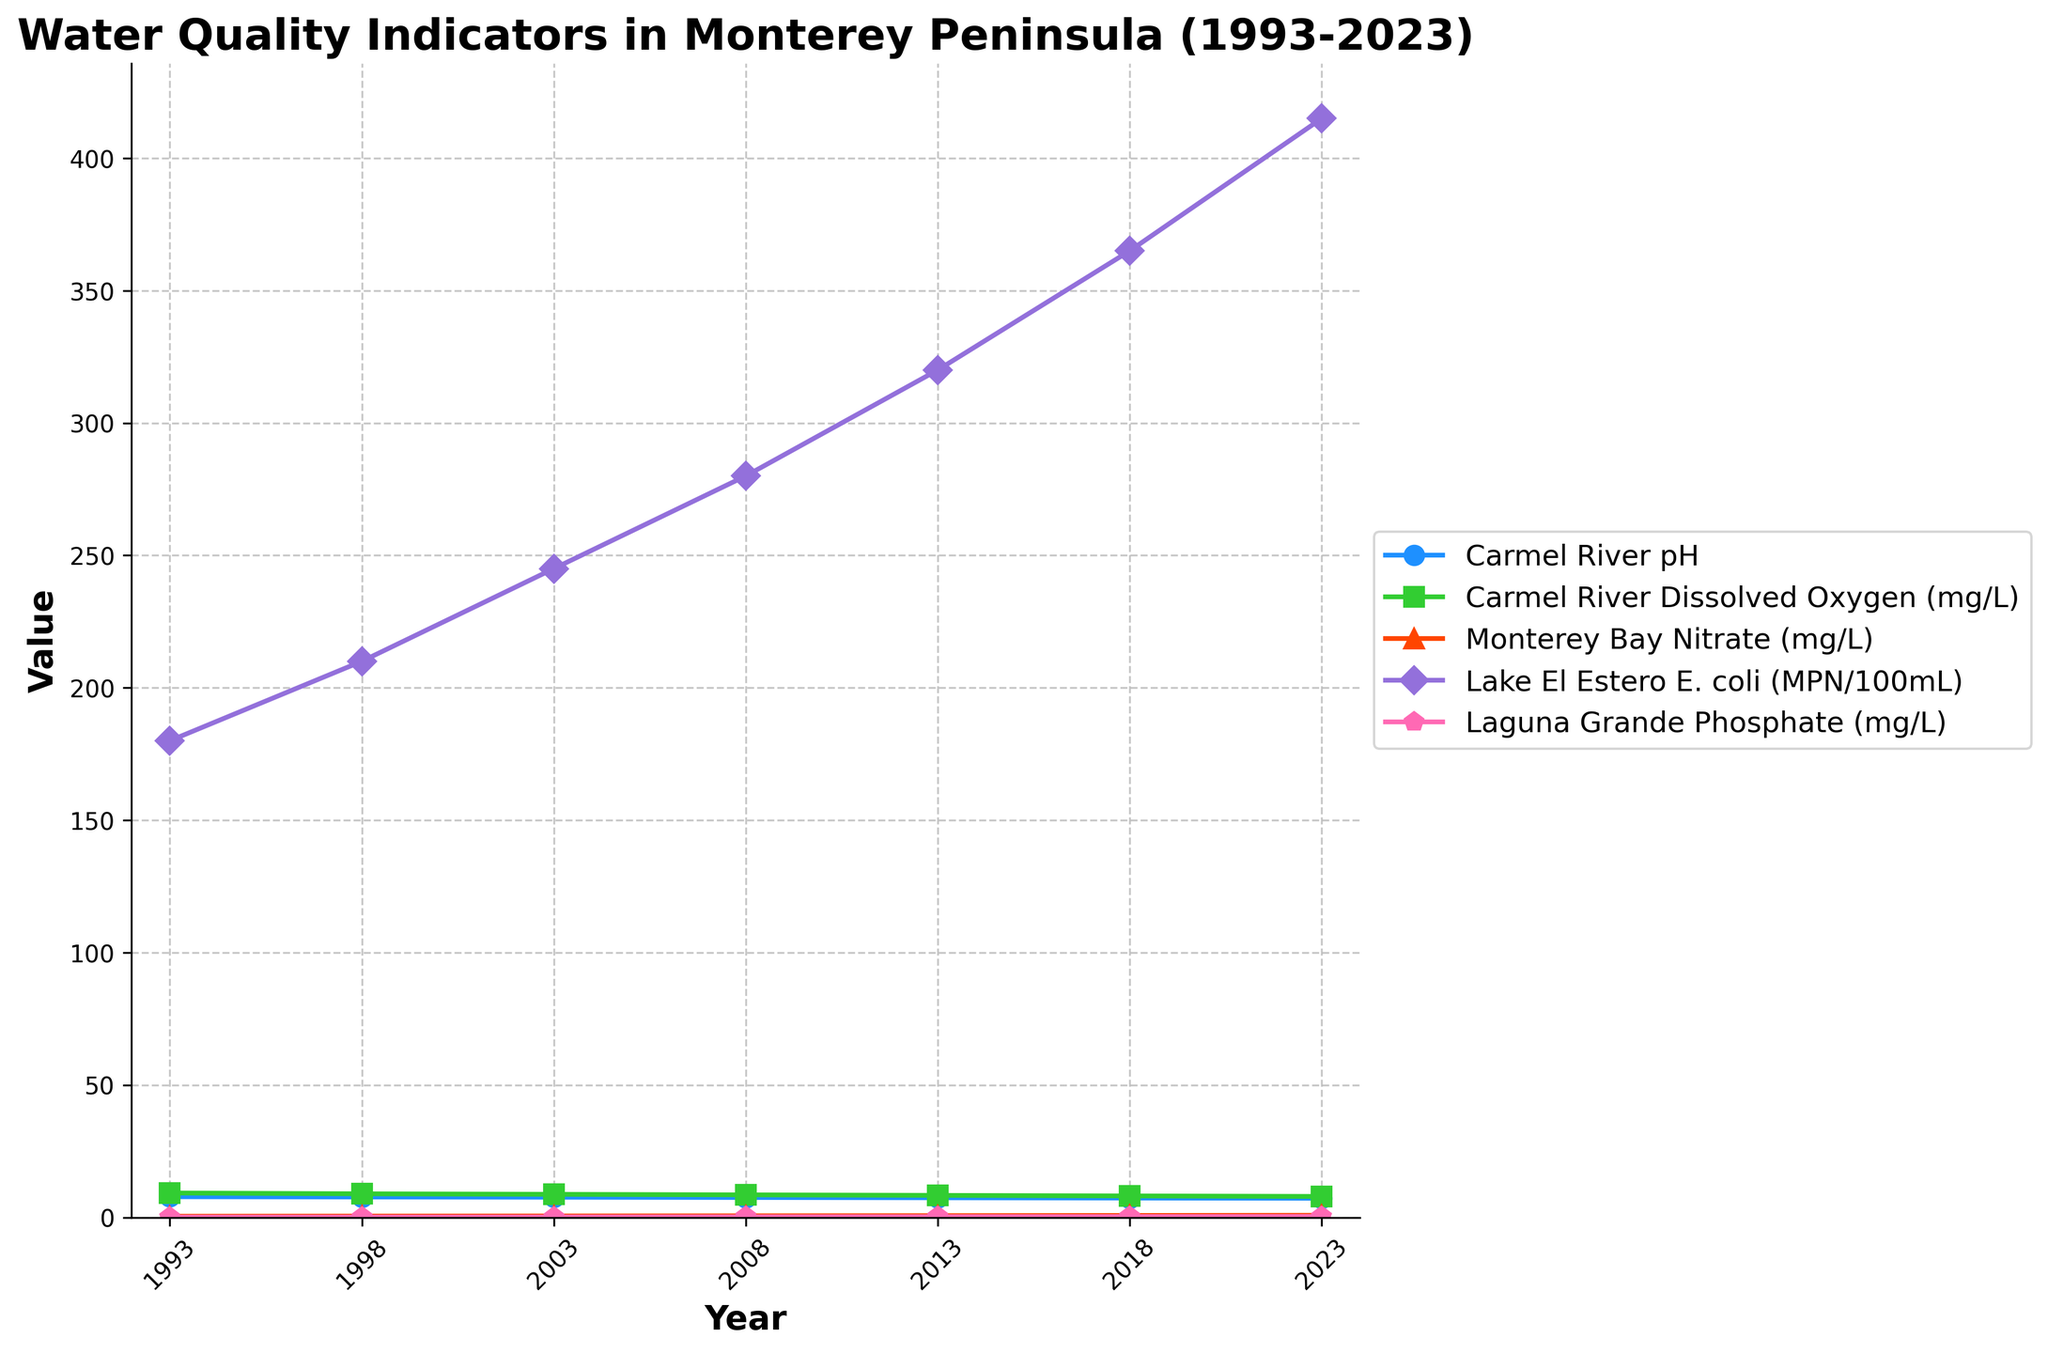What trend is observed in the Carmel River pH from 1993 to 2023? The Carmel River pH decreases from 7.8 in 1993 to 7.2 in 2023. This can be seen by noting the downward slope of the Carmel River pH line on the figure.
Answer: The Carmel River pH decreases How does the level of dissolved oxygen in the Carmel River change over the last 30 years? The Carmel River Dissolved Oxygen decreases from 9.2 mg/L in 1993 to 7.9 mg/L in 2023. The trend is observed as a decreasing line on the graph over the years.
Answer: It decreases Which water quality indicator shows the highest increase over the years? By comparing all the plotted lines, Lake El Estero E. coli shows the steepest increase, going from 180 MPN/100mL in 1993 to 415 MPN/100mL in 2023.
Answer: Lake El Estero E. coli In what year does Monterey Bay Nitrate exceed 0.5 mg/L for the first time? Observing the slope of the Monterey Bay Nitrate line, it first surpasses 0.5 mg/L in 2003.
Answer: 2003 Compare the Carmel River pH in 1998 and 2018. Which year had higher pH levels and by how much? In 1998, the Carmel River pH was 7.7, while in 2018, it was 7.3. To compare, subtract the pH in 2018 from the pH in 1998 (7.7 - 7.3) which equals 0.4.
Answer: 1998 by 0.4 What is the average value of Laguna Grande Phosphate (mg/L) from 1993 to 2023? To calculate the average, sum all the Laguna Grande Phosphate values and divide by the number of years. (0.12 + 0.15 + 0.18 + 0.22 + 0.26 + 0.31 + 0.37) / 7 = 0.23 mg/L.
Answer: 0.23 mg/L How does the trend in Monterey Bay Nitrate compare to the trend in Laguna Grande Phosphate? Both indicators show increasing trends from 1993 to 2023; however, the Monterey Bay Nitrate increases at a more constant and moderate rate, while Laguna Grande Phosphate shows a sharper increase towards the latter years.
Answer: Both are increasing, but Laguna Grande Phosphate increases more sharply Which indicator has the most consistent trend over time, and what does that trend look like? The Carmel River Dissolved Oxygen has the most consistent trend, steadily decreasing over the years. The line representing this indicator has a gentle, consistent downward slope.
Answer: Carmel River Dissolved Oxygen, steadily decreasing From 1993 to 2023, by how much did the Lake El Estero E. coli increase on average per year? Subtract the value in 1993 from the value in 2023, then divide by the number of years: (415 - 180) / (2023 - 1993) = 235 / 30 ≈ 7.83 MPN/100mL per year.
Answer: Approximately 7.83 MPN/100mL per year By how much did the dissolved oxygen level in the Carmel River change between 1993 and 2003? The dissolved oxygen level was 9.2 mg/L in 1993 and 8.7 mg/L in 2003. The change is found by subtracting the 2003 value from the 1993 value: 9.2 - 8.7 = 0.5 mg/L.
Answer: 0.5 mg/L 